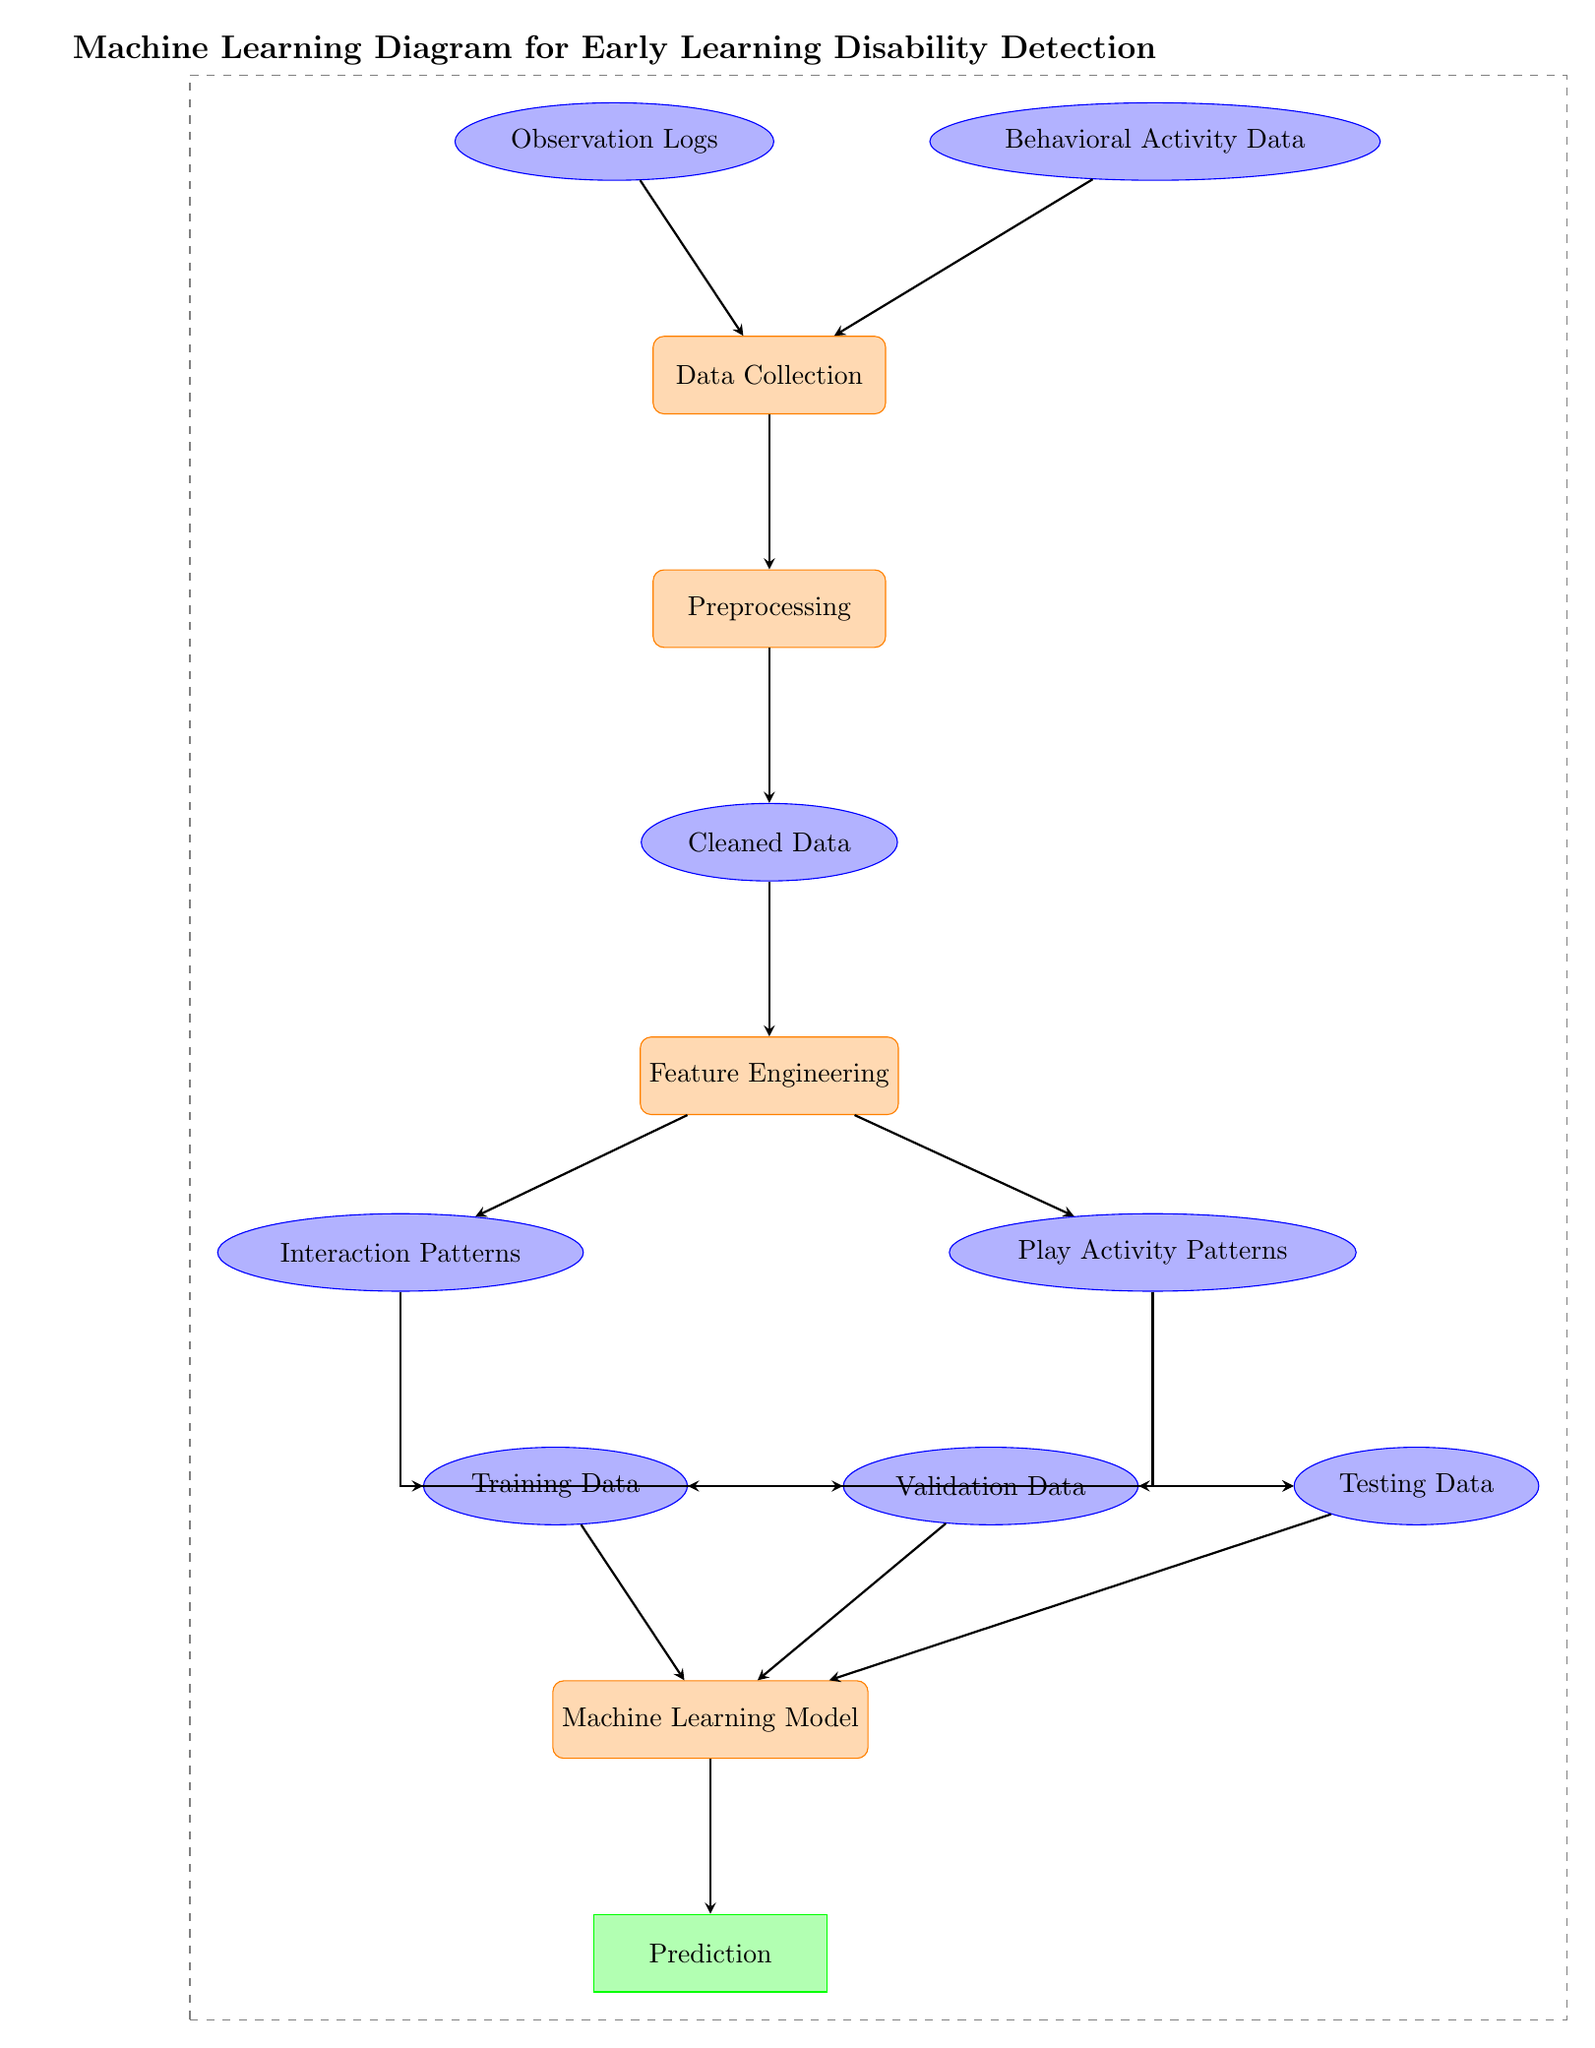What are the two main types of data input to the system? The diagram lists two data inputs: Observation Logs and Behavioral Activity Data. These are represented as data nodes in the diagram, showing they are the initial sources of information for processing.
Answer: Observation Logs, Behavioral Activity Data What is the purpose of the Preprocessing node? The Preprocessing node in the diagram follows the Data Collection node, indicating that it processes the collected data to prepare it for feature engineering. This step is crucial for ensuring that only relevant and clean data is utilized in subsequent stages.
Answer: Cleaned Data How many types of activity patterns are identified for analysis? The diagram depicts two types of activity patterns: Interaction Patterns and Play Activity Patterns. These are outputs from the Feature Engineering node that feed into the Training, Validation, and Testing Data nodes.
Answer: Two Which node receives input from both Interaction Patterns and Play Activity Patterns? The Training Data node receives inputs from both Interaction Patterns and Play Activity Patterns. This indicates that both types of data are essential for training the machine learning model.
Answer: Training Data What is the output of the Machine Learning Model? The output of the Machine Learning Model node is shown as Prediction, which signifies the final result after processing the training, validation, and testing data through the model.
Answer: Prediction What process follows Feature Engineering in the diagram? After Feature Engineering in the diagram, the next process is Training the Machine Learning Model, illustrating a progression where the engineered features are utilized to develop the model.
Answer: Machine Learning Model How many data nodes are connected to the machine learning model? There are three data nodes connected to the Machine Learning Model: Training Data, Validation Data, and Testing Data. This signifies that all these datasets are used to train, validate, and test the model.
Answer: Three What is the role of the arrow in this diagram? The arrows in the diagram represent the direction of data flow between nodes, indicating how information moves through the various processes and data transformations leading to the final prediction.
Answer: Direction of data flow 